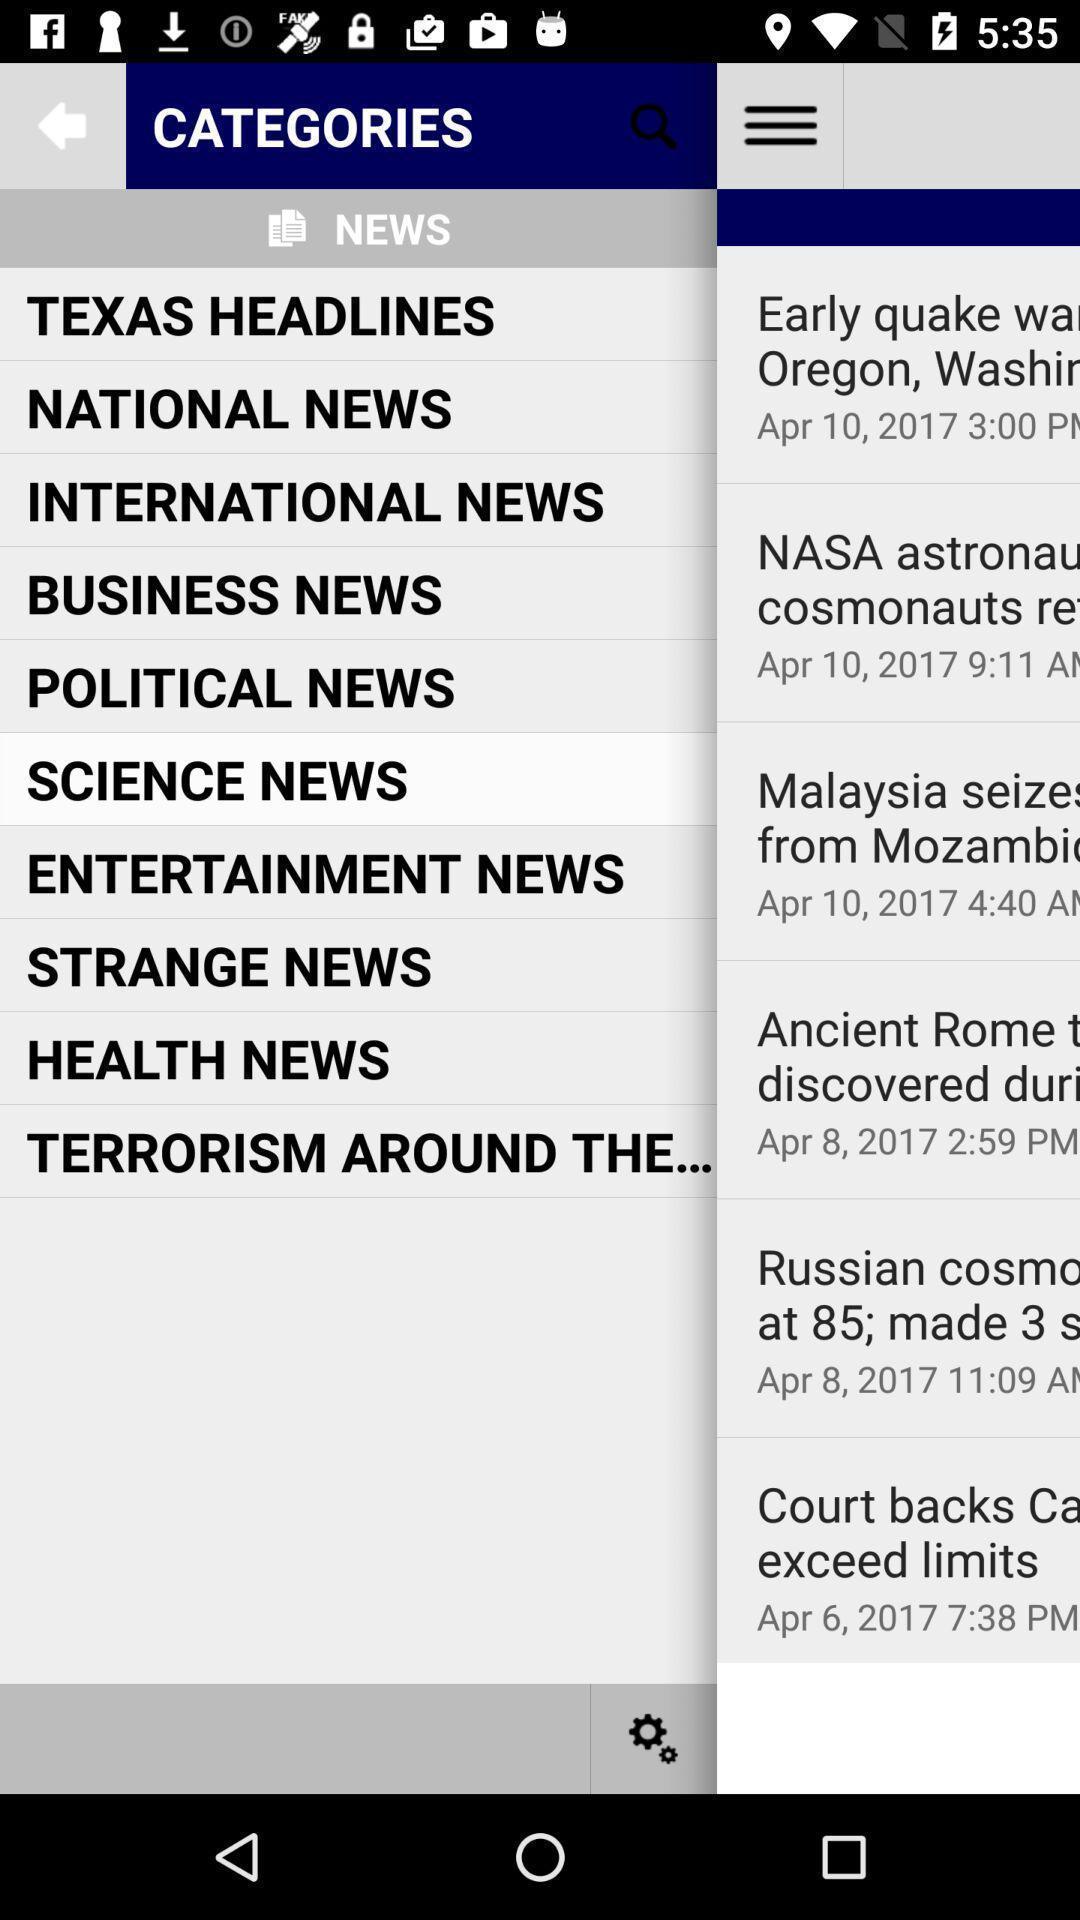Give me a narrative description of this picture. Page showing different categories. 